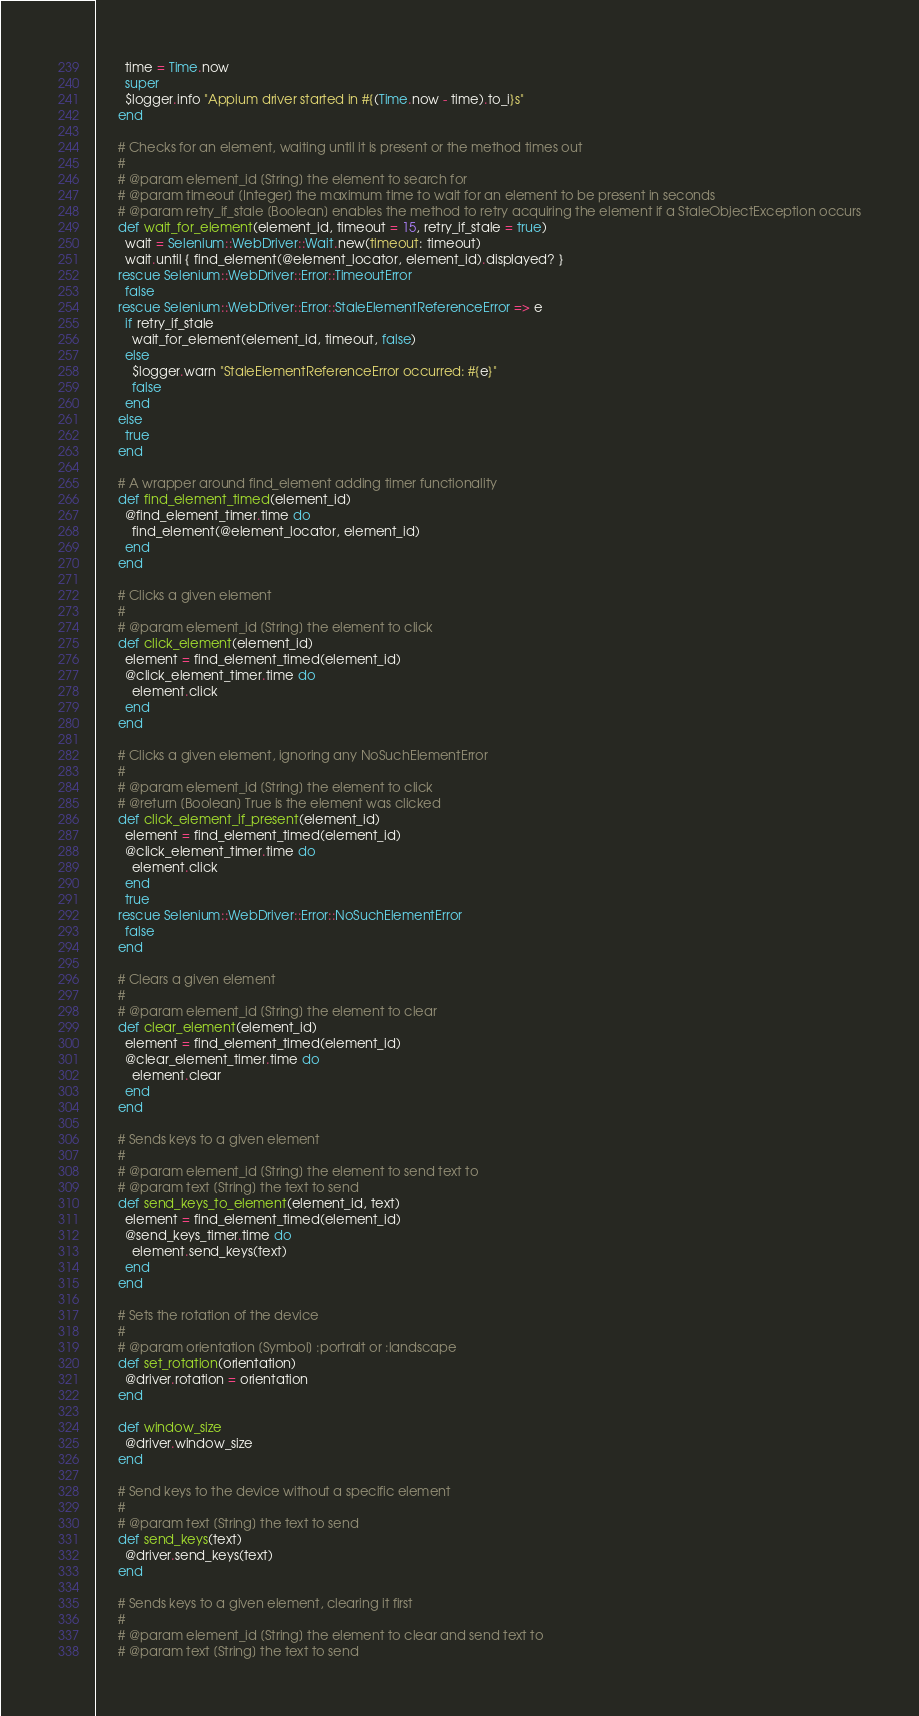Convert code to text. <code><loc_0><loc_0><loc_500><loc_500><_Ruby_>        time = Time.now
        super
        $logger.info "Appium driver started in #{(Time.now - time).to_i}s"
      end

      # Checks for an element, waiting until it is present or the method times out
      #
      # @param element_id [String] the element to search for
      # @param timeout [Integer] the maximum time to wait for an element to be present in seconds
      # @param retry_if_stale [Boolean] enables the method to retry acquiring the element if a StaleObjectException occurs
      def wait_for_element(element_id, timeout = 15, retry_if_stale = true)
        wait = Selenium::WebDriver::Wait.new(timeout: timeout)
        wait.until { find_element(@element_locator, element_id).displayed? }
      rescue Selenium::WebDriver::Error::TimeoutError
        false
      rescue Selenium::WebDriver::Error::StaleElementReferenceError => e
        if retry_if_stale
          wait_for_element(element_id, timeout, false)
        else
          $logger.warn "StaleElementReferenceError occurred: #{e}"
          false
        end
      else
        true
      end

      # A wrapper around find_element adding timer functionality
      def find_element_timed(element_id)
        @find_element_timer.time do
          find_element(@element_locator, element_id)
        end
      end

      # Clicks a given element
      #
      # @param element_id [String] the element to click
      def click_element(element_id)
        element = find_element_timed(element_id)
        @click_element_timer.time do
          element.click
        end
      end

      # Clicks a given element, ignoring any NoSuchElementError
      #
      # @param element_id [String] the element to click
      # @return [Boolean] True is the element was clicked
      def click_element_if_present(element_id)
        element = find_element_timed(element_id)
        @click_element_timer.time do
          element.click
        end
        true
      rescue Selenium::WebDriver::Error::NoSuchElementError
        false
      end

      # Clears a given element
      #
      # @param element_id [String] the element to clear
      def clear_element(element_id)
        element = find_element_timed(element_id)
        @clear_element_timer.time do
          element.clear
        end
      end

      # Sends keys to a given element
      #
      # @param element_id [String] the element to send text to
      # @param text [String] the text to send
      def send_keys_to_element(element_id, text)
        element = find_element_timed(element_id)
        @send_keys_timer.time do
          element.send_keys(text)
        end
      end

      # Sets the rotation of the device
      #
      # @param orientation [Symbol] :portrait or :landscape
      def set_rotation(orientation)
        @driver.rotation = orientation
      end

      def window_size
        @driver.window_size
      end

      # Send keys to the device without a specific element
      #
      # @param text [String] the text to send
      def send_keys(text)
        @driver.send_keys(text)
      end

      # Sends keys to a given element, clearing it first
      #
      # @param element_id [String] the element to clear and send text to
      # @param text [String] the text to send</code> 